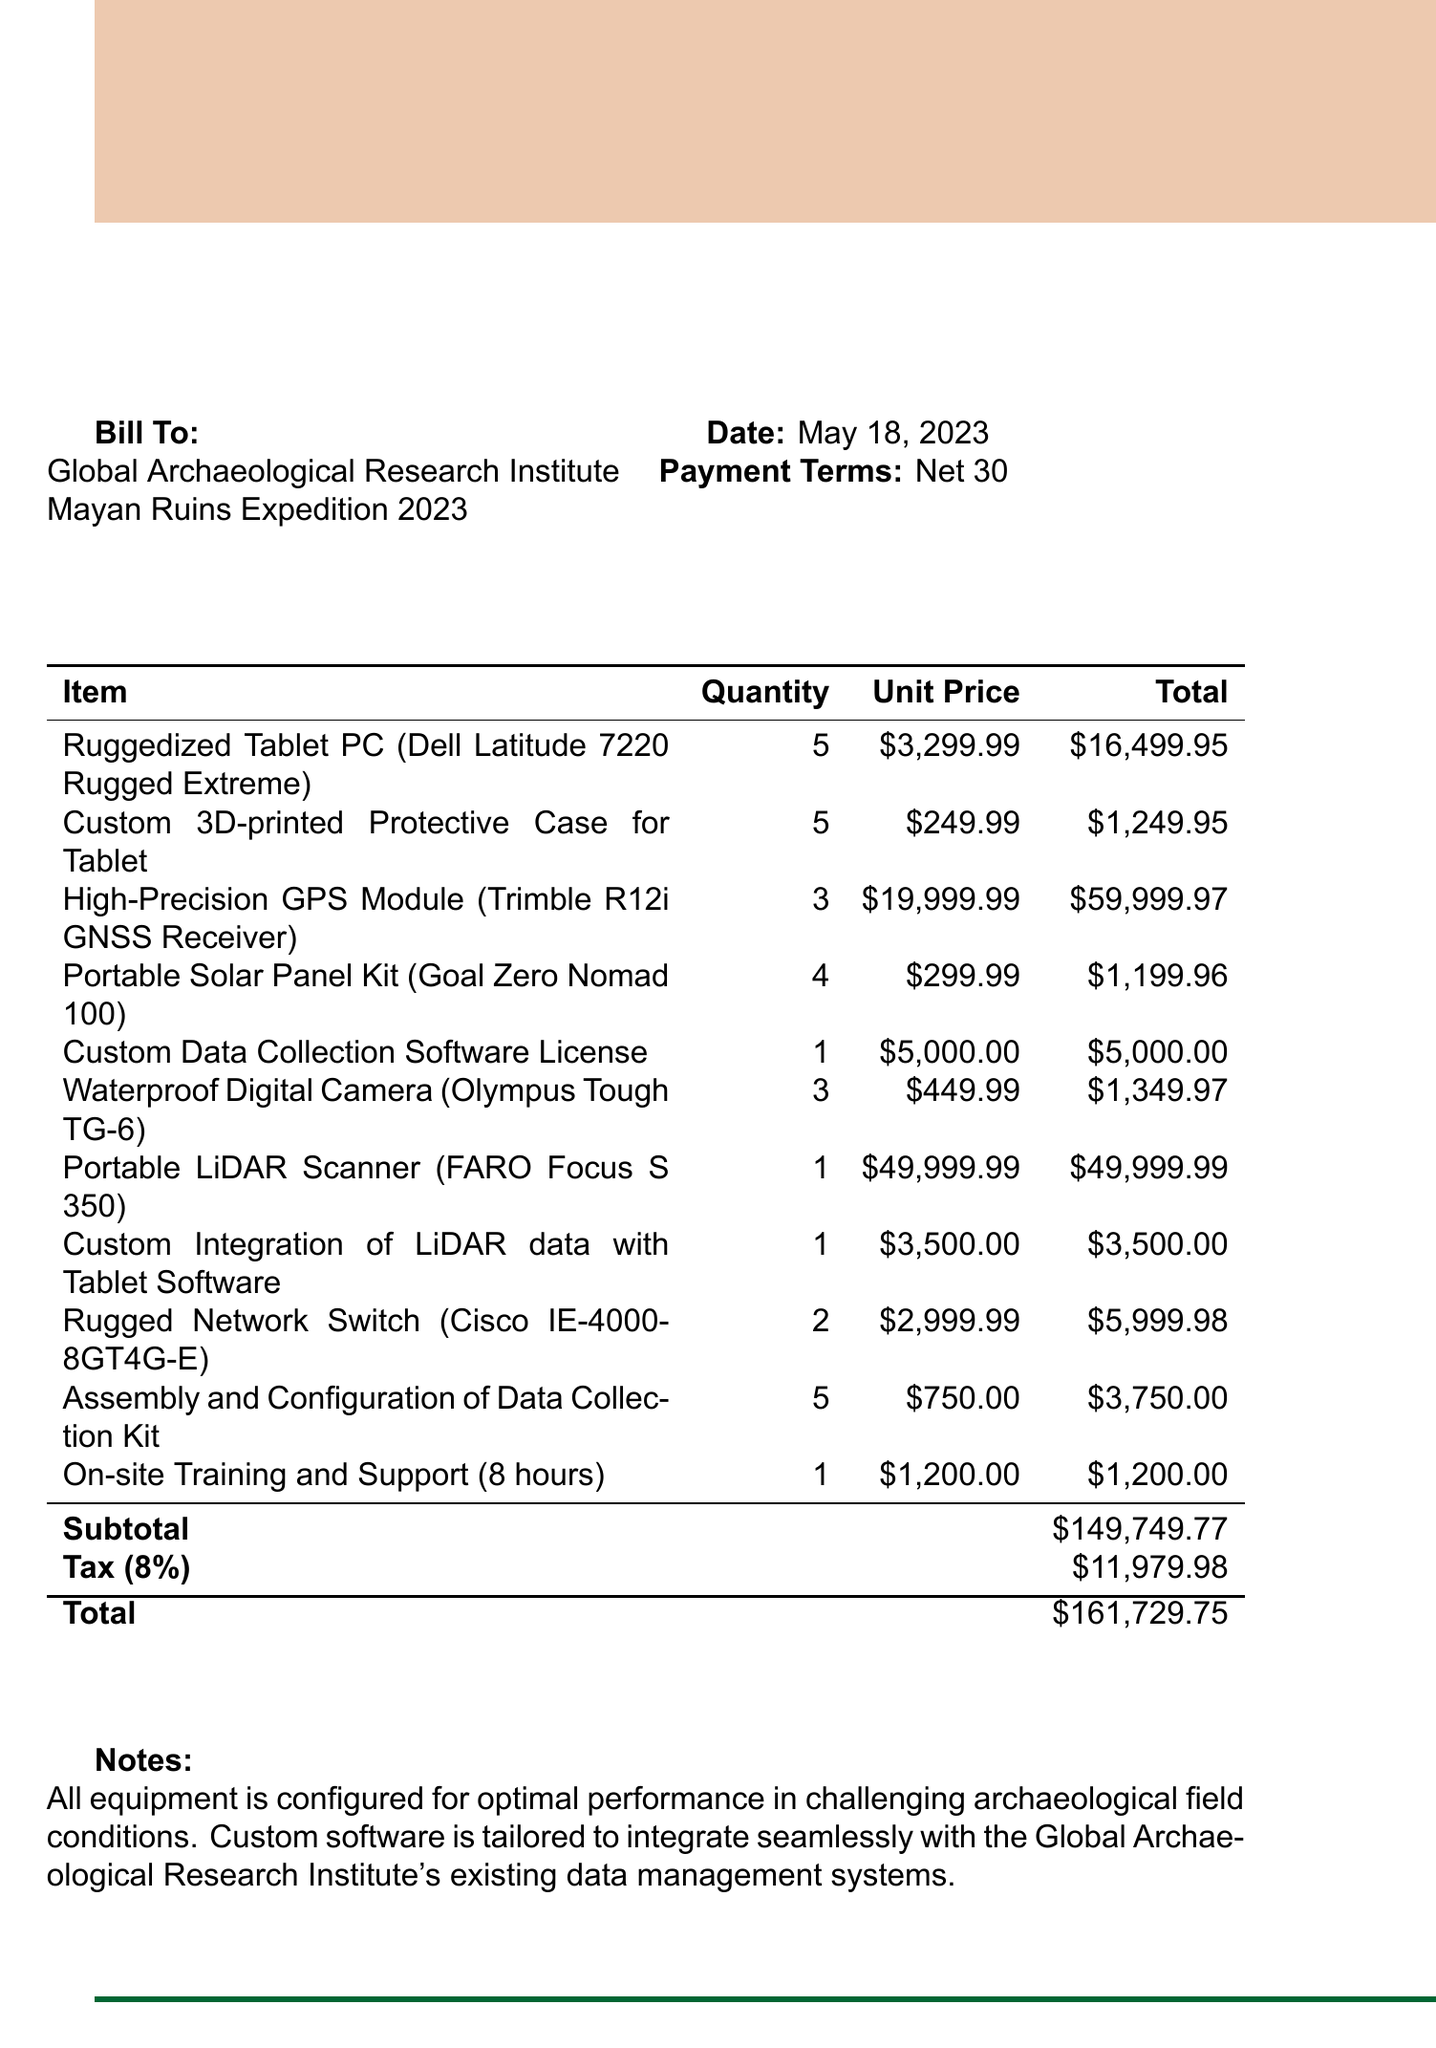what is the invoice number? The invoice number is listed at the top of the document for reference.
Answer: INV-2023-0518 who is the client? The client is specified in the document as the entity receiving the invoice.
Answer: Global Archaeological Research Institute what is the subtotal amount? The subtotal amount represents the total cost of all items before tax is applied.
Answer: $149,749.77 how many ruggedized tablet PCs are included? The quantity of ruggedized tablet PCs is provided under the item description.
Answer: 5 what is the tax rate applied? The tax rate is shown in the document as the percentage applied to the subtotal.
Answer: 8% what is the total amount due? The total amount is the sum of the subtotal and the tax amount, providing the final charge.
Answer: $161,729.75 what item requires on-site training and support? The specific service provided for training is mentioned among the listed items.
Answer: On-site Training and Support (8 hours) how many high-precision GPS modules are ordered? The quantity of high-precision GPS modules is detailed in the list of items.
Answer: 3 what is the payment term? Payment terms specify the timeframe within which payment should be made following the receipt of the invoice.
Answer: Net 30 